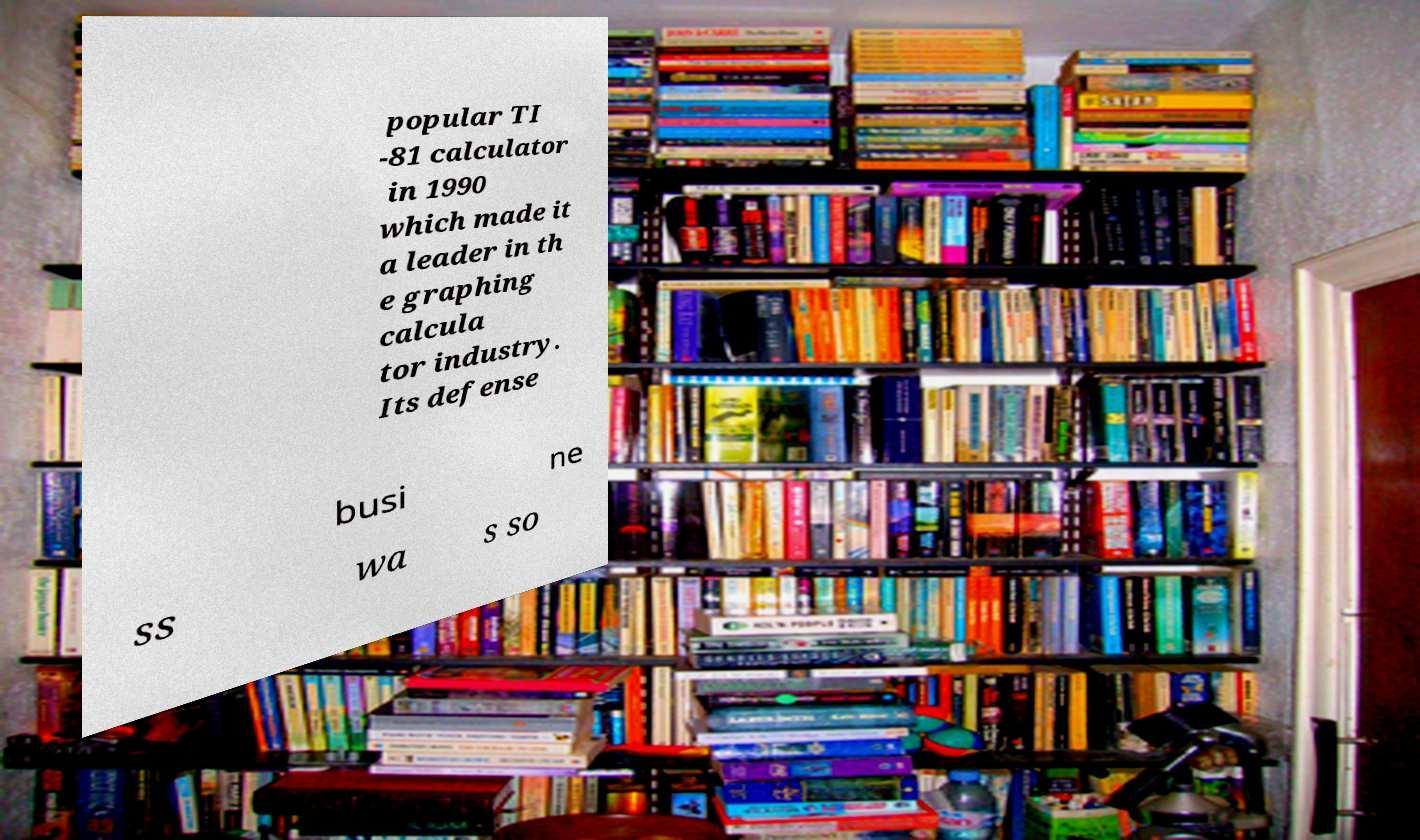Could you extract and type out the text from this image? popular TI -81 calculator in 1990 which made it a leader in th e graphing calcula tor industry. Its defense busi ne ss wa s so 